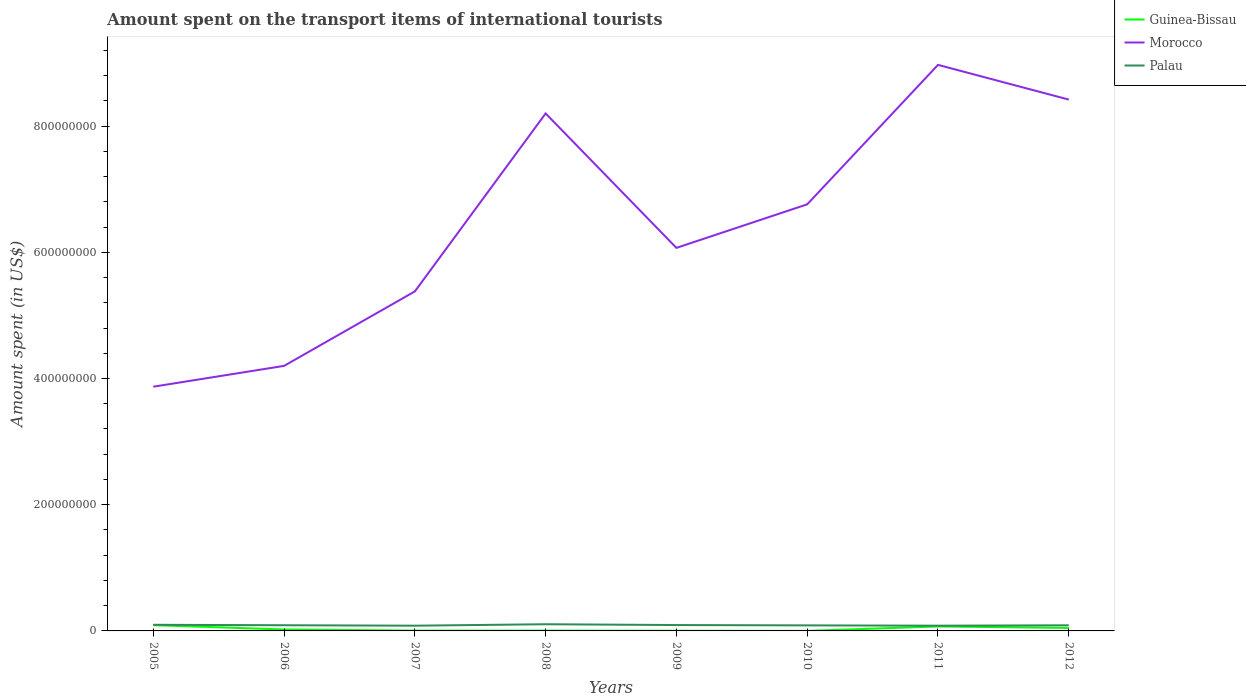How many different coloured lines are there?
Ensure brevity in your answer.  3. Is the number of lines equal to the number of legend labels?
Your response must be concise. Yes. Across all years, what is the maximum amount spent on the transport items of international tourists in Guinea-Bissau?
Provide a short and direct response. 1.00e+05. In which year was the amount spent on the transport items of international tourists in Guinea-Bissau maximum?
Offer a terse response. 2010. What is the total amount spent on the transport items of international tourists in Palau in the graph?
Ensure brevity in your answer.  -6.00e+05. What is the difference between the highest and the second highest amount spent on the transport items of international tourists in Guinea-Bissau?
Provide a short and direct response. 9.00e+06. What is the difference between two consecutive major ticks on the Y-axis?
Offer a very short reply. 2.00e+08. Are the values on the major ticks of Y-axis written in scientific E-notation?
Ensure brevity in your answer.  No. Where does the legend appear in the graph?
Offer a terse response. Top right. How many legend labels are there?
Ensure brevity in your answer.  3. What is the title of the graph?
Your answer should be compact. Amount spent on the transport items of international tourists. What is the label or title of the Y-axis?
Your response must be concise. Amount spent (in US$). What is the Amount spent (in US$) in Guinea-Bissau in 2005?
Your answer should be very brief. 9.10e+06. What is the Amount spent (in US$) of Morocco in 2005?
Make the answer very short. 3.87e+08. What is the Amount spent (in US$) of Palau in 2005?
Your response must be concise. 9.70e+06. What is the Amount spent (in US$) in Guinea-Bissau in 2006?
Your answer should be very brief. 2.30e+06. What is the Amount spent (in US$) of Morocco in 2006?
Offer a terse response. 4.20e+08. What is the Amount spent (in US$) in Palau in 2006?
Keep it short and to the point. 9.00e+06. What is the Amount spent (in US$) of Guinea-Bissau in 2007?
Give a very brief answer. 5.00e+05. What is the Amount spent (in US$) of Morocco in 2007?
Ensure brevity in your answer.  5.38e+08. What is the Amount spent (in US$) of Palau in 2007?
Your response must be concise. 8.30e+06. What is the Amount spent (in US$) of Guinea-Bissau in 2008?
Offer a very short reply. 5.00e+05. What is the Amount spent (in US$) of Morocco in 2008?
Offer a very short reply. 8.20e+08. What is the Amount spent (in US$) of Palau in 2008?
Your answer should be very brief. 1.06e+07. What is the Amount spent (in US$) in Morocco in 2009?
Make the answer very short. 6.07e+08. What is the Amount spent (in US$) of Palau in 2009?
Ensure brevity in your answer.  9.30e+06. What is the Amount spent (in US$) of Morocco in 2010?
Offer a terse response. 6.76e+08. What is the Amount spent (in US$) of Palau in 2010?
Your answer should be very brief. 8.80e+06. What is the Amount spent (in US$) of Guinea-Bissau in 2011?
Make the answer very short. 7.10e+06. What is the Amount spent (in US$) of Morocco in 2011?
Give a very brief answer. 8.97e+08. What is the Amount spent (in US$) in Palau in 2011?
Your response must be concise. 8.30e+06. What is the Amount spent (in US$) of Guinea-Bissau in 2012?
Your response must be concise. 4.70e+06. What is the Amount spent (in US$) in Morocco in 2012?
Provide a short and direct response. 8.42e+08. What is the Amount spent (in US$) of Palau in 2012?
Keep it short and to the point. 8.90e+06. Across all years, what is the maximum Amount spent (in US$) in Guinea-Bissau?
Ensure brevity in your answer.  9.10e+06. Across all years, what is the maximum Amount spent (in US$) in Morocco?
Offer a very short reply. 8.97e+08. Across all years, what is the maximum Amount spent (in US$) of Palau?
Your answer should be compact. 1.06e+07. Across all years, what is the minimum Amount spent (in US$) of Morocco?
Provide a succinct answer. 3.87e+08. Across all years, what is the minimum Amount spent (in US$) in Palau?
Your answer should be compact. 8.30e+06. What is the total Amount spent (in US$) in Guinea-Bissau in the graph?
Ensure brevity in your answer.  2.46e+07. What is the total Amount spent (in US$) of Morocco in the graph?
Provide a short and direct response. 5.19e+09. What is the total Amount spent (in US$) of Palau in the graph?
Give a very brief answer. 7.29e+07. What is the difference between the Amount spent (in US$) in Guinea-Bissau in 2005 and that in 2006?
Offer a very short reply. 6.80e+06. What is the difference between the Amount spent (in US$) in Morocco in 2005 and that in 2006?
Provide a succinct answer. -3.30e+07. What is the difference between the Amount spent (in US$) in Palau in 2005 and that in 2006?
Your answer should be very brief. 7.00e+05. What is the difference between the Amount spent (in US$) in Guinea-Bissau in 2005 and that in 2007?
Offer a very short reply. 8.60e+06. What is the difference between the Amount spent (in US$) of Morocco in 2005 and that in 2007?
Your answer should be very brief. -1.51e+08. What is the difference between the Amount spent (in US$) in Palau in 2005 and that in 2007?
Your answer should be compact. 1.40e+06. What is the difference between the Amount spent (in US$) in Guinea-Bissau in 2005 and that in 2008?
Your response must be concise. 8.60e+06. What is the difference between the Amount spent (in US$) in Morocco in 2005 and that in 2008?
Give a very brief answer. -4.33e+08. What is the difference between the Amount spent (in US$) of Palau in 2005 and that in 2008?
Provide a succinct answer. -9.00e+05. What is the difference between the Amount spent (in US$) in Guinea-Bissau in 2005 and that in 2009?
Your response must be concise. 8.80e+06. What is the difference between the Amount spent (in US$) in Morocco in 2005 and that in 2009?
Your answer should be very brief. -2.20e+08. What is the difference between the Amount spent (in US$) of Palau in 2005 and that in 2009?
Offer a very short reply. 4.00e+05. What is the difference between the Amount spent (in US$) of Guinea-Bissau in 2005 and that in 2010?
Offer a terse response. 9.00e+06. What is the difference between the Amount spent (in US$) of Morocco in 2005 and that in 2010?
Make the answer very short. -2.89e+08. What is the difference between the Amount spent (in US$) of Palau in 2005 and that in 2010?
Provide a short and direct response. 9.00e+05. What is the difference between the Amount spent (in US$) in Morocco in 2005 and that in 2011?
Your answer should be compact. -5.10e+08. What is the difference between the Amount spent (in US$) of Palau in 2005 and that in 2011?
Provide a succinct answer. 1.40e+06. What is the difference between the Amount spent (in US$) in Guinea-Bissau in 2005 and that in 2012?
Offer a very short reply. 4.40e+06. What is the difference between the Amount spent (in US$) of Morocco in 2005 and that in 2012?
Ensure brevity in your answer.  -4.55e+08. What is the difference between the Amount spent (in US$) of Guinea-Bissau in 2006 and that in 2007?
Your answer should be very brief. 1.80e+06. What is the difference between the Amount spent (in US$) of Morocco in 2006 and that in 2007?
Give a very brief answer. -1.18e+08. What is the difference between the Amount spent (in US$) of Palau in 2006 and that in 2007?
Your response must be concise. 7.00e+05. What is the difference between the Amount spent (in US$) of Guinea-Bissau in 2006 and that in 2008?
Offer a terse response. 1.80e+06. What is the difference between the Amount spent (in US$) in Morocco in 2006 and that in 2008?
Your answer should be very brief. -4.00e+08. What is the difference between the Amount spent (in US$) in Palau in 2006 and that in 2008?
Make the answer very short. -1.60e+06. What is the difference between the Amount spent (in US$) of Morocco in 2006 and that in 2009?
Keep it short and to the point. -1.87e+08. What is the difference between the Amount spent (in US$) in Guinea-Bissau in 2006 and that in 2010?
Ensure brevity in your answer.  2.20e+06. What is the difference between the Amount spent (in US$) of Morocco in 2006 and that in 2010?
Keep it short and to the point. -2.56e+08. What is the difference between the Amount spent (in US$) in Palau in 2006 and that in 2010?
Your answer should be compact. 2.00e+05. What is the difference between the Amount spent (in US$) of Guinea-Bissau in 2006 and that in 2011?
Give a very brief answer. -4.80e+06. What is the difference between the Amount spent (in US$) in Morocco in 2006 and that in 2011?
Provide a short and direct response. -4.77e+08. What is the difference between the Amount spent (in US$) in Palau in 2006 and that in 2011?
Your answer should be very brief. 7.00e+05. What is the difference between the Amount spent (in US$) in Guinea-Bissau in 2006 and that in 2012?
Give a very brief answer. -2.40e+06. What is the difference between the Amount spent (in US$) in Morocco in 2006 and that in 2012?
Your answer should be compact. -4.22e+08. What is the difference between the Amount spent (in US$) in Palau in 2006 and that in 2012?
Ensure brevity in your answer.  1.00e+05. What is the difference between the Amount spent (in US$) of Guinea-Bissau in 2007 and that in 2008?
Make the answer very short. 0. What is the difference between the Amount spent (in US$) of Morocco in 2007 and that in 2008?
Your response must be concise. -2.82e+08. What is the difference between the Amount spent (in US$) in Palau in 2007 and that in 2008?
Provide a short and direct response. -2.30e+06. What is the difference between the Amount spent (in US$) of Morocco in 2007 and that in 2009?
Offer a terse response. -6.90e+07. What is the difference between the Amount spent (in US$) in Palau in 2007 and that in 2009?
Your answer should be very brief. -1.00e+06. What is the difference between the Amount spent (in US$) in Guinea-Bissau in 2007 and that in 2010?
Your response must be concise. 4.00e+05. What is the difference between the Amount spent (in US$) of Morocco in 2007 and that in 2010?
Your response must be concise. -1.38e+08. What is the difference between the Amount spent (in US$) of Palau in 2007 and that in 2010?
Provide a short and direct response. -5.00e+05. What is the difference between the Amount spent (in US$) in Guinea-Bissau in 2007 and that in 2011?
Offer a terse response. -6.60e+06. What is the difference between the Amount spent (in US$) of Morocco in 2007 and that in 2011?
Ensure brevity in your answer.  -3.59e+08. What is the difference between the Amount spent (in US$) in Guinea-Bissau in 2007 and that in 2012?
Ensure brevity in your answer.  -4.20e+06. What is the difference between the Amount spent (in US$) of Morocco in 2007 and that in 2012?
Your answer should be very brief. -3.04e+08. What is the difference between the Amount spent (in US$) of Palau in 2007 and that in 2012?
Offer a terse response. -6.00e+05. What is the difference between the Amount spent (in US$) in Guinea-Bissau in 2008 and that in 2009?
Provide a succinct answer. 2.00e+05. What is the difference between the Amount spent (in US$) of Morocco in 2008 and that in 2009?
Your answer should be compact. 2.13e+08. What is the difference between the Amount spent (in US$) of Palau in 2008 and that in 2009?
Ensure brevity in your answer.  1.30e+06. What is the difference between the Amount spent (in US$) in Guinea-Bissau in 2008 and that in 2010?
Provide a succinct answer. 4.00e+05. What is the difference between the Amount spent (in US$) of Morocco in 2008 and that in 2010?
Ensure brevity in your answer.  1.44e+08. What is the difference between the Amount spent (in US$) of Palau in 2008 and that in 2010?
Keep it short and to the point. 1.80e+06. What is the difference between the Amount spent (in US$) in Guinea-Bissau in 2008 and that in 2011?
Provide a short and direct response. -6.60e+06. What is the difference between the Amount spent (in US$) of Morocco in 2008 and that in 2011?
Ensure brevity in your answer.  -7.70e+07. What is the difference between the Amount spent (in US$) of Palau in 2008 and that in 2011?
Ensure brevity in your answer.  2.30e+06. What is the difference between the Amount spent (in US$) of Guinea-Bissau in 2008 and that in 2012?
Keep it short and to the point. -4.20e+06. What is the difference between the Amount spent (in US$) of Morocco in 2008 and that in 2012?
Give a very brief answer. -2.20e+07. What is the difference between the Amount spent (in US$) of Palau in 2008 and that in 2012?
Give a very brief answer. 1.70e+06. What is the difference between the Amount spent (in US$) in Guinea-Bissau in 2009 and that in 2010?
Keep it short and to the point. 2.00e+05. What is the difference between the Amount spent (in US$) of Morocco in 2009 and that in 2010?
Give a very brief answer. -6.90e+07. What is the difference between the Amount spent (in US$) in Guinea-Bissau in 2009 and that in 2011?
Keep it short and to the point. -6.80e+06. What is the difference between the Amount spent (in US$) of Morocco in 2009 and that in 2011?
Provide a succinct answer. -2.90e+08. What is the difference between the Amount spent (in US$) in Palau in 2009 and that in 2011?
Provide a short and direct response. 1.00e+06. What is the difference between the Amount spent (in US$) in Guinea-Bissau in 2009 and that in 2012?
Your response must be concise. -4.40e+06. What is the difference between the Amount spent (in US$) of Morocco in 2009 and that in 2012?
Provide a succinct answer. -2.35e+08. What is the difference between the Amount spent (in US$) of Palau in 2009 and that in 2012?
Provide a succinct answer. 4.00e+05. What is the difference between the Amount spent (in US$) of Guinea-Bissau in 2010 and that in 2011?
Provide a succinct answer. -7.00e+06. What is the difference between the Amount spent (in US$) of Morocco in 2010 and that in 2011?
Your answer should be very brief. -2.21e+08. What is the difference between the Amount spent (in US$) in Guinea-Bissau in 2010 and that in 2012?
Keep it short and to the point. -4.60e+06. What is the difference between the Amount spent (in US$) in Morocco in 2010 and that in 2012?
Keep it short and to the point. -1.66e+08. What is the difference between the Amount spent (in US$) in Guinea-Bissau in 2011 and that in 2012?
Provide a short and direct response. 2.40e+06. What is the difference between the Amount spent (in US$) of Morocco in 2011 and that in 2012?
Your answer should be very brief. 5.50e+07. What is the difference between the Amount spent (in US$) of Palau in 2011 and that in 2012?
Give a very brief answer. -6.00e+05. What is the difference between the Amount spent (in US$) of Guinea-Bissau in 2005 and the Amount spent (in US$) of Morocco in 2006?
Your response must be concise. -4.11e+08. What is the difference between the Amount spent (in US$) in Guinea-Bissau in 2005 and the Amount spent (in US$) in Palau in 2006?
Keep it short and to the point. 1.00e+05. What is the difference between the Amount spent (in US$) of Morocco in 2005 and the Amount spent (in US$) of Palau in 2006?
Keep it short and to the point. 3.78e+08. What is the difference between the Amount spent (in US$) in Guinea-Bissau in 2005 and the Amount spent (in US$) in Morocco in 2007?
Offer a terse response. -5.29e+08. What is the difference between the Amount spent (in US$) of Morocco in 2005 and the Amount spent (in US$) of Palau in 2007?
Your response must be concise. 3.79e+08. What is the difference between the Amount spent (in US$) of Guinea-Bissau in 2005 and the Amount spent (in US$) of Morocco in 2008?
Your response must be concise. -8.11e+08. What is the difference between the Amount spent (in US$) in Guinea-Bissau in 2005 and the Amount spent (in US$) in Palau in 2008?
Your response must be concise. -1.50e+06. What is the difference between the Amount spent (in US$) of Morocco in 2005 and the Amount spent (in US$) of Palau in 2008?
Provide a succinct answer. 3.76e+08. What is the difference between the Amount spent (in US$) of Guinea-Bissau in 2005 and the Amount spent (in US$) of Morocco in 2009?
Offer a terse response. -5.98e+08. What is the difference between the Amount spent (in US$) in Guinea-Bissau in 2005 and the Amount spent (in US$) in Palau in 2009?
Give a very brief answer. -2.00e+05. What is the difference between the Amount spent (in US$) of Morocco in 2005 and the Amount spent (in US$) of Palau in 2009?
Offer a terse response. 3.78e+08. What is the difference between the Amount spent (in US$) of Guinea-Bissau in 2005 and the Amount spent (in US$) of Morocco in 2010?
Your answer should be compact. -6.67e+08. What is the difference between the Amount spent (in US$) in Morocco in 2005 and the Amount spent (in US$) in Palau in 2010?
Your response must be concise. 3.78e+08. What is the difference between the Amount spent (in US$) in Guinea-Bissau in 2005 and the Amount spent (in US$) in Morocco in 2011?
Offer a terse response. -8.88e+08. What is the difference between the Amount spent (in US$) of Guinea-Bissau in 2005 and the Amount spent (in US$) of Palau in 2011?
Keep it short and to the point. 8.00e+05. What is the difference between the Amount spent (in US$) in Morocco in 2005 and the Amount spent (in US$) in Palau in 2011?
Keep it short and to the point. 3.79e+08. What is the difference between the Amount spent (in US$) in Guinea-Bissau in 2005 and the Amount spent (in US$) in Morocco in 2012?
Your answer should be compact. -8.33e+08. What is the difference between the Amount spent (in US$) of Morocco in 2005 and the Amount spent (in US$) of Palau in 2012?
Ensure brevity in your answer.  3.78e+08. What is the difference between the Amount spent (in US$) of Guinea-Bissau in 2006 and the Amount spent (in US$) of Morocco in 2007?
Make the answer very short. -5.36e+08. What is the difference between the Amount spent (in US$) of Guinea-Bissau in 2006 and the Amount spent (in US$) of Palau in 2007?
Your answer should be compact. -6.00e+06. What is the difference between the Amount spent (in US$) in Morocco in 2006 and the Amount spent (in US$) in Palau in 2007?
Give a very brief answer. 4.12e+08. What is the difference between the Amount spent (in US$) of Guinea-Bissau in 2006 and the Amount spent (in US$) of Morocco in 2008?
Keep it short and to the point. -8.18e+08. What is the difference between the Amount spent (in US$) of Guinea-Bissau in 2006 and the Amount spent (in US$) of Palau in 2008?
Your response must be concise. -8.30e+06. What is the difference between the Amount spent (in US$) in Morocco in 2006 and the Amount spent (in US$) in Palau in 2008?
Keep it short and to the point. 4.09e+08. What is the difference between the Amount spent (in US$) in Guinea-Bissau in 2006 and the Amount spent (in US$) in Morocco in 2009?
Provide a succinct answer. -6.05e+08. What is the difference between the Amount spent (in US$) in Guinea-Bissau in 2006 and the Amount spent (in US$) in Palau in 2009?
Ensure brevity in your answer.  -7.00e+06. What is the difference between the Amount spent (in US$) of Morocco in 2006 and the Amount spent (in US$) of Palau in 2009?
Provide a succinct answer. 4.11e+08. What is the difference between the Amount spent (in US$) of Guinea-Bissau in 2006 and the Amount spent (in US$) of Morocco in 2010?
Make the answer very short. -6.74e+08. What is the difference between the Amount spent (in US$) in Guinea-Bissau in 2006 and the Amount spent (in US$) in Palau in 2010?
Keep it short and to the point. -6.50e+06. What is the difference between the Amount spent (in US$) of Morocco in 2006 and the Amount spent (in US$) of Palau in 2010?
Provide a short and direct response. 4.11e+08. What is the difference between the Amount spent (in US$) in Guinea-Bissau in 2006 and the Amount spent (in US$) in Morocco in 2011?
Provide a short and direct response. -8.95e+08. What is the difference between the Amount spent (in US$) in Guinea-Bissau in 2006 and the Amount spent (in US$) in Palau in 2011?
Provide a succinct answer. -6.00e+06. What is the difference between the Amount spent (in US$) in Morocco in 2006 and the Amount spent (in US$) in Palau in 2011?
Your answer should be compact. 4.12e+08. What is the difference between the Amount spent (in US$) of Guinea-Bissau in 2006 and the Amount spent (in US$) of Morocco in 2012?
Your answer should be compact. -8.40e+08. What is the difference between the Amount spent (in US$) of Guinea-Bissau in 2006 and the Amount spent (in US$) of Palau in 2012?
Offer a very short reply. -6.60e+06. What is the difference between the Amount spent (in US$) of Morocco in 2006 and the Amount spent (in US$) of Palau in 2012?
Your answer should be very brief. 4.11e+08. What is the difference between the Amount spent (in US$) in Guinea-Bissau in 2007 and the Amount spent (in US$) in Morocco in 2008?
Ensure brevity in your answer.  -8.20e+08. What is the difference between the Amount spent (in US$) in Guinea-Bissau in 2007 and the Amount spent (in US$) in Palau in 2008?
Your answer should be very brief. -1.01e+07. What is the difference between the Amount spent (in US$) in Morocco in 2007 and the Amount spent (in US$) in Palau in 2008?
Ensure brevity in your answer.  5.27e+08. What is the difference between the Amount spent (in US$) in Guinea-Bissau in 2007 and the Amount spent (in US$) in Morocco in 2009?
Provide a short and direct response. -6.06e+08. What is the difference between the Amount spent (in US$) in Guinea-Bissau in 2007 and the Amount spent (in US$) in Palau in 2009?
Your answer should be very brief. -8.80e+06. What is the difference between the Amount spent (in US$) of Morocco in 2007 and the Amount spent (in US$) of Palau in 2009?
Make the answer very short. 5.29e+08. What is the difference between the Amount spent (in US$) in Guinea-Bissau in 2007 and the Amount spent (in US$) in Morocco in 2010?
Offer a very short reply. -6.76e+08. What is the difference between the Amount spent (in US$) in Guinea-Bissau in 2007 and the Amount spent (in US$) in Palau in 2010?
Your answer should be compact. -8.30e+06. What is the difference between the Amount spent (in US$) in Morocco in 2007 and the Amount spent (in US$) in Palau in 2010?
Your answer should be very brief. 5.29e+08. What is the difference between the Amount spent (in US$) in Guinea-Bissau in 2007 and the Amount spent (in US$) in Morocco in 2011?
Provide a short and direct response. -8.96e+08. What is the difference between the Amount spent (in US$) in Guinea-Bissau in 2007 and the Amount spent (in US$) in Palau in 2011?
Make the answer very short. -7.80e+06. What is the difference between the Amount spent (in US$) of Morocco in 2007 and the Amount spent (in US$) of Palau in 2011?
Offer a terse response. 5.30e+08. What is the difference between the Amount spent (in US$) of Guinea-Bissau in 2007 and the Amount spent (in US$) of Morocco in 2012?
Offer a terse response. -8.42e+08. What is the difference between the Amount spent (in US$) in Guinea-Bissau in 2007 and the Amount spent (in US$) in Palau in 2012?
Ensure brevity in your answer.  -8.40e+06. What is the difference between the Amount spent (in US$) in Morocco in 2007 and the Amount spent (in US$) in Palau in 2012?
Your answer should be compact. 5.29e+08. What is the difference between the Amount spent (in US$) of Guinea-Bissau in 2008 and the Amount spent (in US$) of Morocco in 2009?
Give a very brief answer. -6.06e+08. What is the difference between the Amount spent (in US$) in Guinea-Bissau in 2008 and the Amount spent (in US$) in Palau in 2009?
Make the answer very short. -8.80e+06. What is the difference between the Amount spent (in US$) in Morocco in 2008 and the Amount spent (in US$) in Palau in 2009?
Offer a terse response. 8.11e+08. What is the difference between the Amount spent (in US$) in Guinea-Bissau in 2008 and the Amount spent (in US$) in Morocco in 2010?
Provide a short and direct response. -6.76e+08. What is the difference between the Amount spent (in US$) of Guinea-Bissau in 2008 and the Amount spent (in US$) of Palau in 2010?
Give a very brief answer. -8.30e+06. What is the difference between the Amount spent (in US$) in Morocco in 2008 and the Amount spent (in US$) in Palau in 2010?
Give a very brief answer. 8.11e+08. What is the difference between the Amount spent (in US$) of Guinea-Bissau in 2008 and the Amount spent (in US$) of Morocco in 2011?
Offer a very short reply. -8.96e+08. What is the difference between the Amount spent (in US$) in Guinea-Bissau in 2008 and the Amount spent (in US$) in Palau in 2011?
Provide a short and direct response. -7.80e+06. What is the difference between the Amount spent (in US$) of Morocco in 2008 and the Amount spent (in US$) of Palau in 2011?
Offer a terse response. 8.12e+08. What is the difference between the Amount spent (in US$) of Guinea-Bissau in 2008 and the Amount spent (in US$) of Morocco in 2012?
Offer a terse response. -8.42e+08. What is the difference between the Amount spent (in US$) of Guinea-Bissau in 2008 and the Amount spent (in US$) of Palau in 2012?
Make the answer very short. -8.40e+06. What is the difference between the Amount spent (in US$) of Morocco in 2008 and the Amount spent (in US$) of Palau in 2012?
Keep it short and to the point. 8.11e+08. What is the difference between the Amount spent (in US$) of Guinea-Bissau in 2009 and the Amount spent (in US$) of Morocco in 2010?
Offer a very short reply. -6.76e+08. What is the difference between the Amount spent (in US$) in Guinea-Bissau in 2009 and the Amount spent (in US$) in Palau in 2010?
Keep it short and to the point. -8.50e+06. What is the difference between the Amount spent (in US$) of Morocco in 2009 and the Amount spent (in US$) of Palau in 2010?
Provide a short and direct response. 5.98e+08. What is the difference between the Amount spent (in US$) of Guinea-Bissau in 2009 and the Amount spent (in US$) of Morocco in 2011?
Your answer should be compact. -8.97e+08. What is the difference between the Amount spent (in US$) of Guinea-Bissau in 2009 and the Amount spent (in US$) of Palau in 2011?
Offer a very short reply. -8.00e+06. What is the difference between the Amount spent (in US$) in Morocco in 2009 and the Amount spent (in US$) in Palau in 2011?
Make the answer very short. 5.99e+08. What is the difference between the Amount spent (in US$) in Guinea-Bissau in 2009 and the Amount spent (in US$) in Morocco in 2012?
Your response must be concise. -8.42e+08. What is the difference between the Amount spent (in US$) in Guinea-Bissau in 2009 and the Amount spent (in US$) in Palau in 2012?
Offer a very short reply. -8.60e+06. What is the difference between the Amount spent (in US$) of Morocco in 2009 and the Amount spent (in US$) of Palau in 2012?
Provide a short and direct response. 5.98e+08. What is the difference between the Amount spent (in US$) of Guinea-Bissau in 2010 and the Amount spent (in US$) of Morocco in 2011?
Provide a succinct answer. -8.97e+08. What is the difference between the Amount spent (in US$) of Guinea-Bissau in 2010 and the Amount spent (in US$) of Palau in 2011?
Your response must be concise. -8.20e+06. What is the difference between the Amount spent (in US$) in Morocco in 2010 and the Amount spent (in US$) in Palau in 2011?
Make the answer very short. 6.68e+08. What is the difference between the Amount spent (in US$) of Guinea-Bissau in 2010 and the Amount spent (in US$) of Morocco in 2012?
Provide a succinct answer. -8.42e+08. What is the difference between the Amount spent (in US$) of Guinea-Bissau in 2010 and the Amount spent (in US$) of Palau in 2012?
Make the answer very short. -8.80e+06. What is the difference between the Amount spent (in US$) in Morocco in 2010 and the Amount spent (in US$) in Palau in 2012?
Ensure brevity in your answer.  6.67e+08. What is the difference between the Amount spent (in US$) of Guinea-Bissau in 2011 and the Amount spent (in US$) of Morocco in 2012?
Your answer should be very brief. -8.35e+08. What is the difference between the Amount spent (in US$) of Guinea-Bissau in 2011 and the Amount spent (in US$) of Palau in 2012?
Provide a short and direct response. -1.80e+06. What is the difference between the Amount spent (in US$) in Morocco in 2011 and the Amount spent (in US$) in Palau in 2012?
Ensure brevity in your answer.  8.88e+08. What is the average Amount spent (in US$) in Guinea-Bissau per year?
Provide a succinct answer. 3.08e+06. What is the average Amount spent (in US$) of Morocco per year?
Keep it short and to the point. 6.48e+08. What is the average Amount spent (in US$) of Palau per year?
Ensure brevity in your answer.  9.11e+06. In the year 2005, what is the difference between the Amount spent (in US$) of Guinea-Bissau and Amount spent (in US$) of Morocco?
Offer a terse response. -3.78e+08. In the year 2005, what is the difference between the Amount spent (in US$) of Guinea-Bissau and Amount spent (in US$) of Palau?
Keep it short and to the point. -6.00e+05. In the year 2005, what is the difference between the Amount spent (in US$) in Morocco and Amount spent (in US$) in Palau?
Your answer should be compact. 3.77e+08. In the year 2006, what is the difference between the Amount spent (in US$) in Guinea-Bissau and Amount spent (in US$) in Morocco?
Offer a terse response. -4.18e+08. In the year 2006, what is the difference between the Amount spent (in US$) in Guinea-Bissau and Amount spent (in US$) in Palau?
Your answer should be very brief. -6.70e+06. In the year 2006, what is the difference between the Amount spent (in US$) of Morocco and Amount spent (in US$) of Palau?
Your response must be concise. 4.11e+08. In the year 2007, what is the difference between the Amount spent (in US$) in Guinea-Bissau and Amount spent (in US$) in Morocco?
Keep it short and to the point. -5.38e+08. In the year 2007, what is the difference between the Amount spent (in US$) in Guinea-Bissau and Amount spent (in US$) in Palau?
Give a very brief answer. -7.80e+06. In the year 2007, what is the difference between the Amount spent (in US$) in Morocco and Amount spent (in US$) in Palau?
Offer a terse response. 5.30e+08. In the year 2008, what is the difference between the Amount spent (in US$) of Guinea-Bissau and Amount spent (in US$) of Morocco?
Your answer should be compact. -8.20e+08. In the year 2008, what is the difference between the Amount spent (in US$) in Guinea-Bissau and Amount spent (in US$) in Palau?
Offer a terse response. -1.01e+07. In the year 2008, what is the difference between the Amount spent (in US$) of Morocco and Amount spent (in US$) of Palau?
Keep it short and to the point. 8.09e+08. In the year 2009, what is the difference between the Amount spent (in US$) of Guinea-Bissau and Amount spent (in US$) of Morocco?
Give a very brief answer. -6.07e+08. In the year 2009, what is the difference between the Amount spent (in US$) of Guinea-Bissau and Amount spent (in US$) of Palau?
Make the answer very short. -9.00e+06. In the year 2009, what is the difference between the Amount spent (in US$) of Morocco and Amount spent (in US$) of Palau?
Keep it short and to the point. 5.98e+08. In the year 2010, what is the difference between the Amount spent (in US$) in Guinea-Bissau and Amount spent (in US$) in Morocco?
Offer a terse response. -6.76e+08. In the year 2010, what is the difference between the Amount spent (in US$) in Guinea-Bissau and Amount spent (in US$) in Palau?
Your response must be concise. -8.70e+06. In the year 2010, what is the difference between the Amount spent (in US$) in Morocco and Amount spent (in US$) in Palau?
Ensure brevity in your answer.  6.67e+08. In the year 2011, what is the difference between the Amount spent (in US$) in Guinea-Bissau and Amount spent (in US$) in Morocco?
Make the answer very short. -8.90e+08. In the year 2011, what is the difference between the Amount spent (in US$) of Guinea-Bissau and Amount spent (in US$) of Palau?
Provide a short and direct response. -1.20e+06. In the year 2011, what is the difference between the Amount spent (in US$) of Morocco and Amount spent (in US$) of Palau?
Keep it short and to the point. 8.89e+08. In the year 2012, what is the difference between the Amount spent (in US$) of Guinea-Bissau and Amount spent (in US$) of Morocco?
Your answer should be very brief. -8.37e+08. In the year 2012, what is the difference between the Amount spent (in US$) in Guinea-Bissau and Amount spent (in US$) in Palau?
Offer a terse response. -4.20e+06. In the year 2012, what is the difference between the Amount spent (in US$) in Morocco and Amount spent (in US$) in Palau?
Offer a terse response. 8.33e+08. What is the ratio of the Amount spent (in US$) of Guinea-Bissau in 2005 to that in 2006?
Your answer should be compact. 3.96. What is the ratio of the Amount spent (in US$) of Morocco in 2005 to that in 2006?
Your answer should be very brief. 0.92. What is the ratio of the Amount spent (in US$) of Palau in 2005 to that in 2006?
Make the answer very short. 1.08. What is the ratio of the Amount spent (in US$) of Guinea-Bissau in 2005 to that in 2007?
Keep it short and to the point. 18.2. What is the ratio of the Amount spent (in US$) in Morocco in 2005 to that in 2007?
Offer a very short reply. 0.72. What is the ratio of the Amount spent (in US$) in Palau in 2005 to that in 2007?
Ensure brevity in your answer.  1.17. What is the ratio of the Amount spent (in US$) in Guinea-Bissau in 2005 to that in 2008?
Offer a very short reply. 18.2. What is the ratio of the Amount spent (in US$) of Morocco in 2005 to that in 2008?
Your answer should be compact. 0.47. What is the ratio of the Amount spent (in US$) in Palau in 2005 to that in 2008?
Your answer should be very brief. 0.92. What is the ratio of the Amount spent (in US$) in Guinea-Bissau in 2005 to that in 2009?
Provide a short and direct response. 30.33. What is the ratio of the Amount spent (in US$) in Morocco in 2005 to that in 2009?
Ensure brevity in your answer.  0.64. What is the ratio of the Amount spent (in US$) in Palau in 2005 to that in 2009?
Your answer should be compact. 1.04. What is the ratio of the Amount spent (in US$) of Guinea-Bissau in 2005 to that in 2010?
Keep it short and to the point. 91. What is the ratio of the Amount spent (in US$) of Morocco in 2005 to that in 2010?
Make the answer very short. 0.57. What is the ratio of the Amount spent (in US$) of Palau in 2005 to that in 2010?
Offer a very short reply. 1.1. What is the ratio of the Amount spent (in US$) of Guinea-Bissau in 2005 to that in 2011?
Ensure brevity in your answer.  1.28. What is the ratio of the Amount spent (in US$) of Morocco in 2005 to that in 2011?
Your answer should be very brief. 0.43. What is the ratio of the Amount spent (in US$) in Palau in 2005 to that in 2011?
Your response must be concise. 1.17. What is the ratio of the Amount spent (in US$) of Guinea-Bissau in 2005 to that in 2012?
Ensure brevity in your answer.  1.94. What is the ratio of the Amount spent (in US$) of Morocco in 2005 to that in 2012?
Make the answer very short. 0.46. What is the ratio of the Amount spent (in US$) of Palau in 2005 to that in 2012?
Your response must be concise. 1.09. What is the ratio of the Amount spent (in US$) in Guinea-Bissau in 2006 to that in 2007?
Ensure brevity in your answer.  4.6. What is the ratio of the Amount spent (in US$) in Morocco in 2006 to that in 2007?
Your response must be concise. 0.78. What is the ratio of the Amount spent (in US$) in Palau in 2006 to that in 2007?
Your answer should be compact. 1.08. What is the ratio of the Amount spent (in US$) in Morocco in 2006 to that in 2008?
Provide a succinct answer. 0.51. What is the ratio of the Amount spent (in US$) in Palau in 2006 to that in 2008?
Give a very brief answer. 0.85. What is the ratio of the Amount spent (in US$) of Guinea-Bissau in 2006 to that in 2009?
Provide a short and direct response. 7.67. What is the ratio of the Amount spent (in US$) in Morocco in 2006 to that in 2009?
Your answer should be compact. 0.69. What is the ratio of the Amount spent (in US$) in Palau in 2006 to that in 2009?
Keep it short and to the point. 0.97. What is the ratio of the Amount spent (in US$) of Morocco in 2006 to that in 2010?
Give a very brief answer. 0.62. What is the ratio of the Amount spent (in US$) in Palau in 2006 to that in 2010?
Keep it short and to the point. 1.02. What is the ratio of the Amount spent (in US$) in Guinea-Bissau in 2006 to that in 2011?
Your answer should be very brief. 0.32. What is the ratio of the Amount spent (in US$) in Morocco in 2006 to that in 2011?
Make the answer very short. 0.47. What is the ratio of the Amount spent (in US$) of Palau in 2006 to that in 2011?
Your answer should be compact. 1.08. What is the ratio of the Amount spent (in US$) of Guinea-Bissau in 2006 to that in 2012?
Provide a short and direct response. 0.49. What is the ratio of the Amount spent (in US$) of Morocco in 2006 to that in 2012?
Offer a very short reply. 0.5. What is the ratio of the Amount spent (in US$) in Palau in 2006 to that in 2012?
Give a very brief answer. 1.01. What is the ratio of the Amount spent (in US$) of Morocco in 2007 to that in 2008?
Your response must be concise. 0.66. What is the ratio of the Amount spent (in US$) in Palau in 2007 to that in 2008?
Your answer should be very brief. 0.78. What is the ratio of the Amount spent (in US$) in Morocco in 2007 to that in 2009?
Make the answer very short. 0.89. What is the ratio of the Amount spent (in US$) in Palau in 2007 to that in 2009?
Provide a succinct answer. 0.89. What is the ratio of the Amount spent (in US$) in Morocco in 2007 to that in 2010?
Your answer should be very brief. 0.8. What is the ratio of the Amount spent (in US$) in Palau in 2007 to that in 2010?
Your answer should be very brief. 0.94. What is the ratio of the Amount spent (in US$) of Guinea-Bissau in 2007 to that in 2011?
Your response must be concise. 0.07. What is the ratio of the Amount spent (in US$) of Morocco in 2007 to that in 2011?
Your answer should be very brief. 0.6. What is the ratio of the Amount spent (in US$) in Guinea-Bissau in 2007 to that in 2012?
Make the answer very short. 0.11. What is the ratio of the Amount spent (in US$) of Morocco in 2007 to that in 2012?
Keep it short and to the point. 0.64. What is the ratio of the Amount spent (in US$) of Palau in 2007 to that in 2012?
Give a very brief answer. 0.93. What is the ratio of the Amount spent (in US$) in Morocco in 2008 to that in 2009?
Your response must be concise. 1.35. What is the ratio of the Amount spent (in US$) in Palau in 2008 to that in 2009?
Your response must be concise. 1.14. What is the ratio of the Amount spent (in US$) in Guinea-Bissau in 2008 to that in 2010?
Provide a short and direct response. 5. What is the ratio of the Amount spent (in US$) in Morocco in 2008 to that in 2010?
Offer a very short reply. 1.21. What is the ratio of the Amount spent (in US$) of Palau in 2008 to that in 2010?
Make the answer very short. 1.2. What is the ratio of the Amount spent (in US$) of Guinea-Bissau in 2008 to that in 2011?
Your response must be concise. 0.07. What is the ratio of the Amount spent (in US$) of Morocco in 2008 to that in 2011?
Keep it short and to the point. 0.91. What is the ratio of the Amount spent (in US$) in Palau in 2008 to that in 2011?
Give a very brief answer. 1.28. What is the ratio of the Amount spent (in US$) in Guinea-Bissau in 2008 to that in 2012?
Offer a terse response. 0.11. What is the ratio of the Amount spent (in US$) of Morocco in 2008 to that in 2012?
Offer a very short reply. 0.97. What is the ratio of the Amount spent (in US$) of Palau in 2008 to that in 2012?
Provide a short and direct response. 1.19. What is the ratio of the Amount spent (in US$) of Morocco in 2009 to that in 2010?
Give a very brief answer. 0.9. What is the ratio of the Amount spent (in US$) in Palau in 2009 to that in 2010?
Provide a succinct answer. 1.06. What is the ratio of the Amount spent (in US$) in Guinea-Bissau in 2009 to that in 2011?
Make the answer very short. 0.04. What is the ratio of the Amount spent (in US$) of Morocco in 2009 to that in 2011?
Ensure brevity in your answer.  0.68. What is the ratio of the Amount spent (in US$) in Palau in 2009 to that in 2011?
Your response must be concise. 1.12. What is the ratio of the Amount spent (in US$) of Guinea-Bissau in 2009 to that in 2012?
Give a very brief answer. 0.06. What is the ratio of the Amount spent (in US$) in Morocco in 2009 to that in 2012?
Make the answer very short. 0.72. What is the ratio of the Amount spent (in US$) in Palau in 2009 to that in 2012?
Offer a terse response. 1.04. What is the ratio of the Amount spent (in US$) in Guinea-Bissau in 2010 to that in 2011?
Ensure brevity in your answer.  0.01. What is the ratio of the Amount spent (in US$) of Morocco in 2010 to that in 2011?
Give a very brief answer. 0.75. What is the ratio of the Amount spent (in US$) in Palau in 2010 to that in 2011?
Your answer should be compact. 1.06. What is the ratio of the Amount spent (in US$) in Guinea-Bissau in 2010 to that in 2012?
Your answer should be very brief. 0.02. What is the ratio of the Amount spent (in US$) in Morocco in 2010 to that in 2012?
Offer a terse response. 0.8. What is the ratio of the Amount spent (in US$) in Palau in 2010 to that in 2012?
Keep it short and to the point. 0.99. What is the ratio of the Amount spent (in US$) in Guinea-Bissau in 2011 to that in 2012?
Your answer should be compact. 1.51. What is the ratio of the Amount spent (in US$) in Morocco in 2011 to that in 2012?
Provide a short and direct response. 1.07. What is the ratio of the Amount spent (in US$) of Palau in 2011 to that in 2012?
Provide a short and direct response. 0.93. What is the difference between the highest and the second highest Amount spent (in US$) in Guinea-Bissau?
Provide a short and direct response. 2.00e+06. What is the difference between the highest and the second highest Amount spent (in US$) of Morocco?
Your answer should be very brief. 5.50e+07. What is the difference between the highest and the second highest Amount spent (in US$) of Palau?
Give a very brief answer. 9.00e+05. What is the difference between the highest and the lowest Amount spent (in US$) of Guinea-Bissau?
Offer a very short reply. 9.00e+06. What is the difference between the highest and the lowest Amount spent (in US$) of Morocco?
Your response must be concise. 5.10e+08. What is the difference between the highest and the lowest Amount spent (in US$) in Palau?
Make the answer very short. 2.30e+06. 